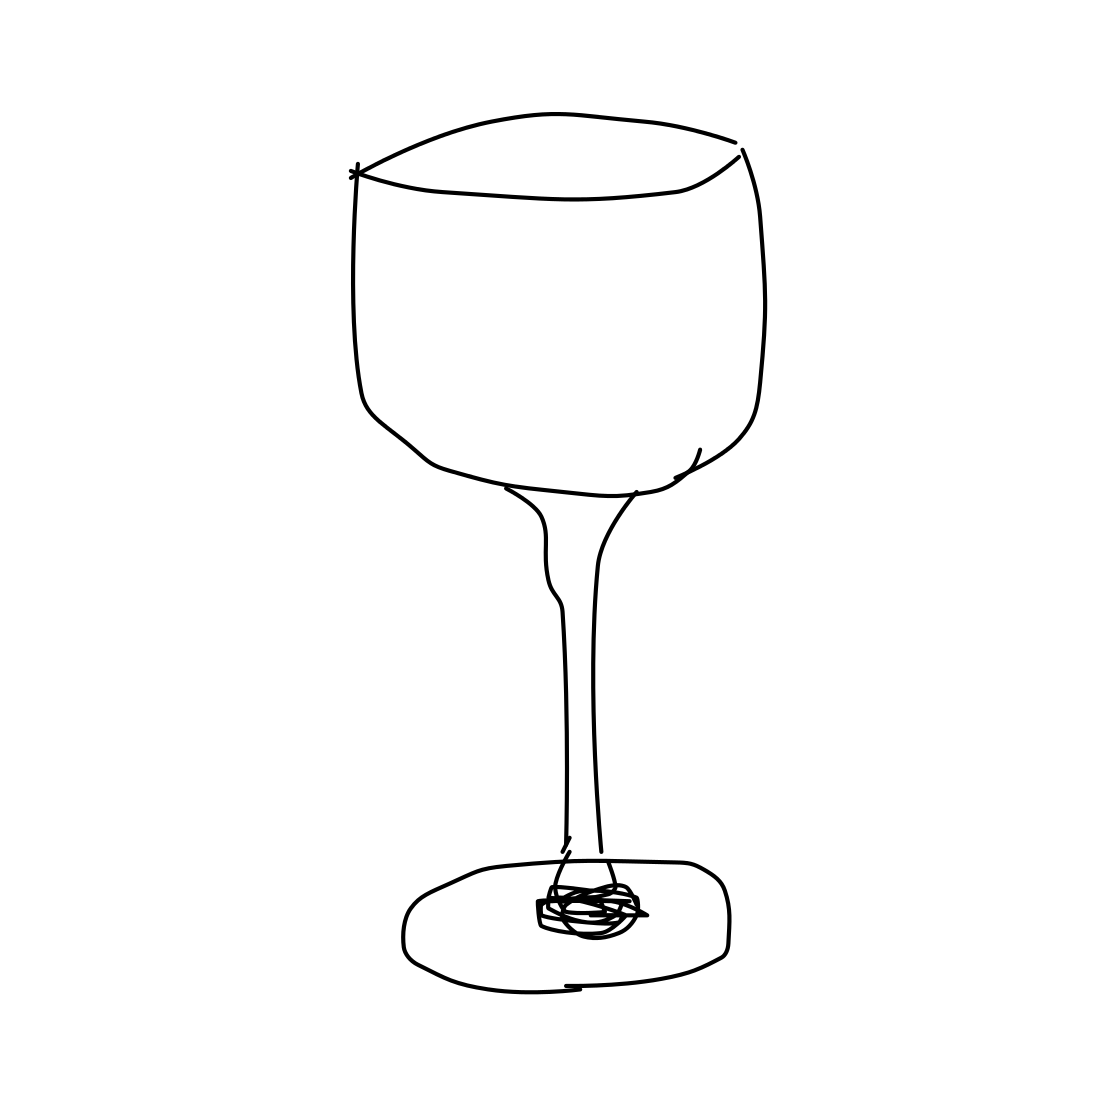Is the wineglass shown appropriate for a formal occasion? While the drawing is quite simplistic, the glass it represents with its tall stem and generous bowl would be quite appropriate for formal occasions. Wineglasses of this style are often selected for their aesthetic appeal and the way they enhance the wine-tasting experience. 